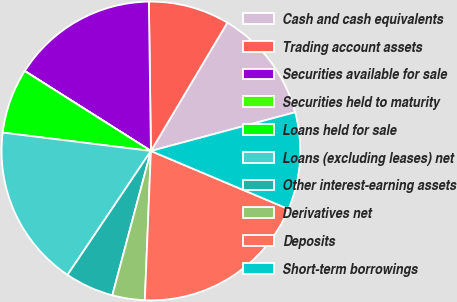Convert chart to OTSL. <chart><loc_0><loc_0><loc_500><loc_500><pie_chart><fcel>Cash and cash equivalents<fcel>Trading account assets<fcel>Securities available for sale<fcel>Securities held to maturity<fcel>Loans held for sale<fcel>Loans (excluding leases) net<fcel>Other interest-earning assets<fcel>Derivatives net<fcel>Deposits<fcel>Short-term borrowings<nl><fcel>12.28%<fcel>8.77%<fcel>15.79%<fcel>0.01%<fcel>7.02%<fcel>17.54%<fcel>5.27%<fcel>3.51%<fcel>19.29%<fcel>10.53%<nl></chart> 